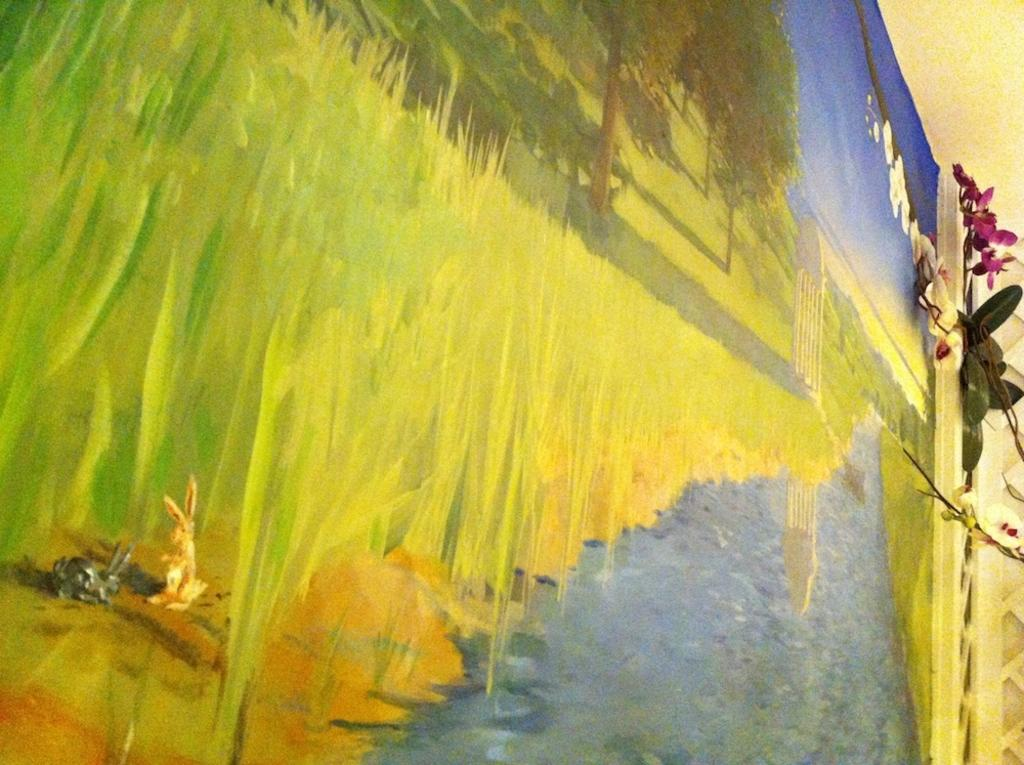What is the main subject of the image? The image contains a painting. What elements are included in the painting? The painting includes water, grass, a tree, and a rabbit. What else is visible in the painting? The painting includes the sky. What type of sound can be heard coming from the rabbit in the painting? There is no sound present in the image, as it is a painting and not a real-life scene. 